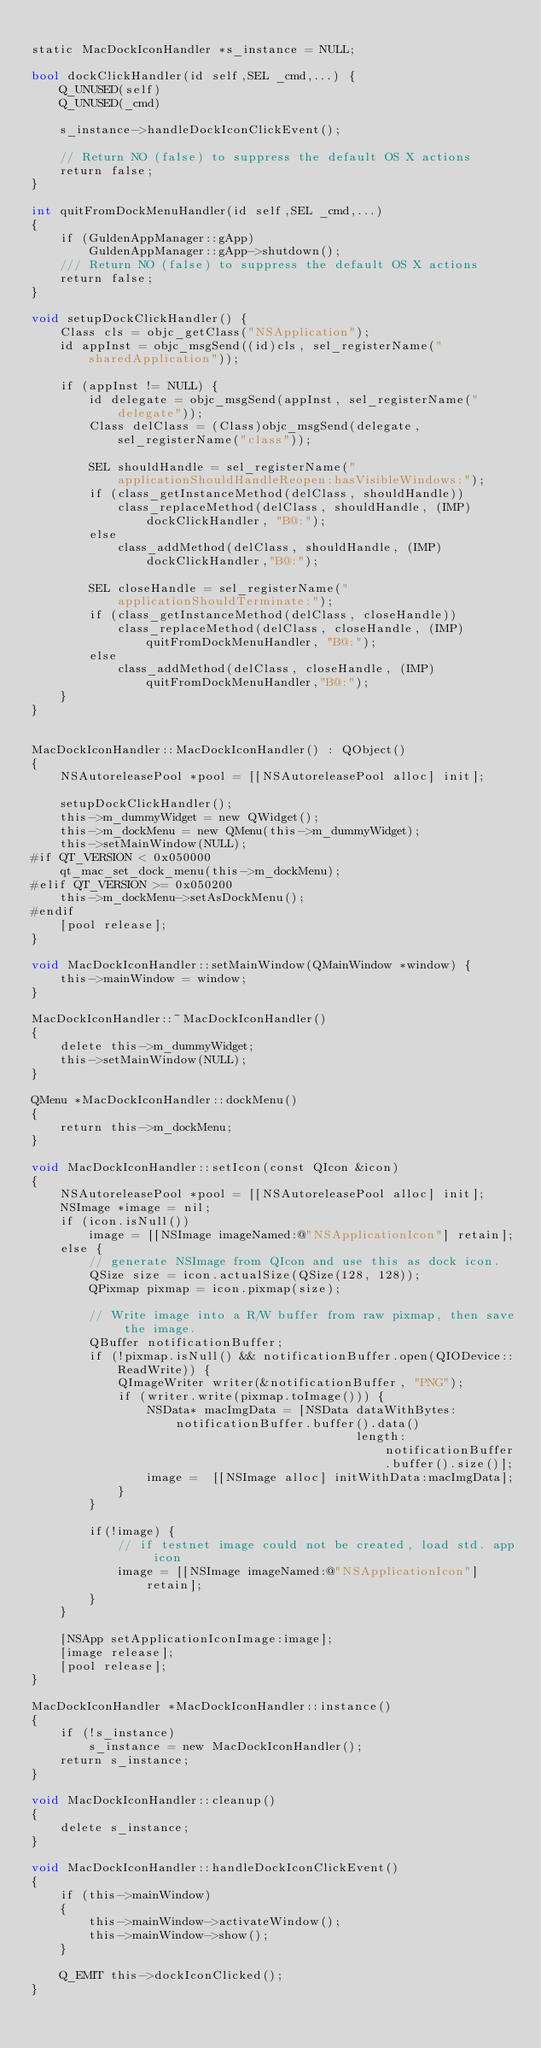Convert code to text. <code><loc_0><loc_0><loc_500><loc_500><_ObjectiveC_>
static MacDockIconHandler *s_instance = NULL;

bool dockClickHandler(id self,SEL _cmd,...) {
    Q_UNUSED(self)
    Q_UNUSED(_cmd)

    s_instance->handleDockIconClickEvent();

    // Return NO (false) to suppress the default OS X actions
    return false;
}

int quitFromDockMenuHandler(id self,SEL _cmd,...)
{
    if (GuldenAppManager::gApp)
        GuldenAppManager::gApp->shutdown();
    /// Return NO (false) to suppress the default OS X actions
    return false;
}

void setupDockClickHandler() {
    Class cls = objc_getClass("NSApplication");
    id appInst = objc_msgSend((id)cls, sel_registerName("sharedApplication"));

    if (appInst != NULL) {
        id delegate = objc_msgSend(appInst, sel_registerName("delegate"));
        Class delClass = (Class)objc_msgSend(delegate,  sel_registerName("class"));

        SEL shouldHandle = sel_registerName("applicationShouldHandleReopen:hasVisibleWindows:");
        if (class_getInstanceMethod(delClass, shouldHandle))
            class_replaceMethod(delClass, shouldHandle, (IMP)dockClickHandler, "B@:");
        else
            class_addMethod(delClass, shouldHandle, (IMP)dockClickHandler,"B@:");

        SEL closeHandle = sel_registerName("applicationShouldTerminate:");
        if (class_getInstanceMethod(delClass, closeHandle))
            class_replaceMethod(delClass, closeHandle, (IMP)quitFromDockMenuHandler, "B@:");
        else
            class_addMethod(delClass, closeHandle, (IMP)quitFromDockMenuHandler,"B@:");
    }
}


MacDockIconHandler::MacDockIconHandler() : QObject()
{
    NSAutoreleasePool *pool = [[NSAutoreleasePool alloc] init];

    setupDockClickHandler();
    this->m_dummyWidget = new QWidget();
    this->m_dockMenu = new QMenu(this->m_dummyWidget);
    this->setMainWindow(NULL);
#if QT_VERSION < 0x050000
    qt_mac_set_dock_menu(this->m_dockMenu);
#elif QT_VERSION >= 0x050200
    this->m_dockMenu->setAsDockMenu();
#endif
    [pool release];
}

void MacDockIconHandler::setMainWindow(QMainWindow *window) {
    this->mainWindow = window;
}

MacDockIconHandler::~MacDockIconHandler()
{
    delete this->m_dummyWidget;
    this->setMainWindow(NULL);
}

QMenu *MacDockIconHandler::dockMenu()
{
    return this->m_dockMenu;
}

void MacDockIconHandler::setIcon(const QIcon &icon)
{
    NSAutoreleasePool *pool = [[NSAutoreleasePool alloc] init];
    NSImage *image = nil;
    if (icon.isNull())
        image = [[NSImage imageNamed:@"NSApplicationIcon"] retain];
    else {
        // generate NSImage from QIcon and use this as dock icon.
        QSize size = icon.actualSize(QSize(128, 128));
        QPixmap pixmap = icon.pixmap(size);

        // Write image into a R/W buffer from raw pixmap, then save the image.
        QBuffer notificationBuffer;
        if (!pixmap.isNull() && notificationBuffer.open(QIODevice::ReadWrite)) {
            QImageWriter writer(&notificationBuffer, "PNG");
            if (writer.write(pixmap.toImage())) {
                NSData* macImgData = [NSData dataWithBytes:notificationBuffer.buffer().data()
                                             length:notificationBuffer.buffer().size()];
                image =  [[NSImage alloc] initWithData:macImgData];
            }
        }

        if(!image) {
            // if testnet image could not be created, load std. app icon
            image = [[NSImage imageNamed:@"NSApplicationIcon"] retain];
        }
    }

    [NSApp setApplicationIconImage:image];
    [image release];
    [pool release];
}

MacDockIconHandler *MacDockIconHandler::instance()
{
    if (!s_instance)
        s_instance = new MacDockIconHandler();
    return s_instance;
}

void MacDockIconHandler::cleanup()
{
    delete s_instance;
}

void MacDockIconHandler::handleDockIconClickEvent()
{
    if (this->mainWindow)
    {
        this->mainWindow->activateWindow();
        this->mainWindow->show();
    }

    Q_EMIT this->dockIconClicked();
}
</code> 